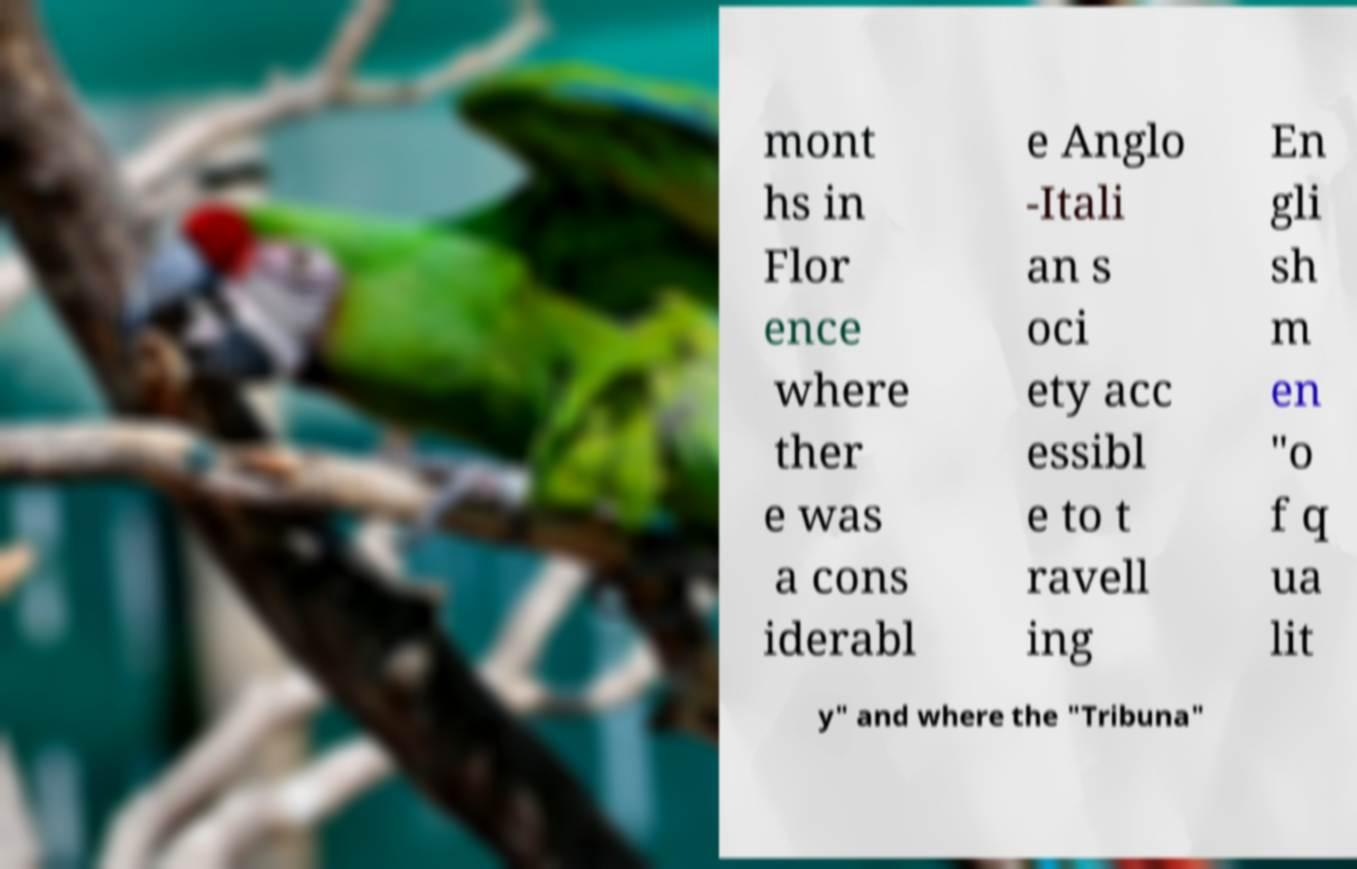Please read and relay the text visible in this image. What does it say? mont hs in Flor ence where ther e was a cons iderabl e Anglo -Itali an s oci ety acc essibl e to t ravell ing En gli sh m en "o f q ua lit y" and where the "Tribuna" 